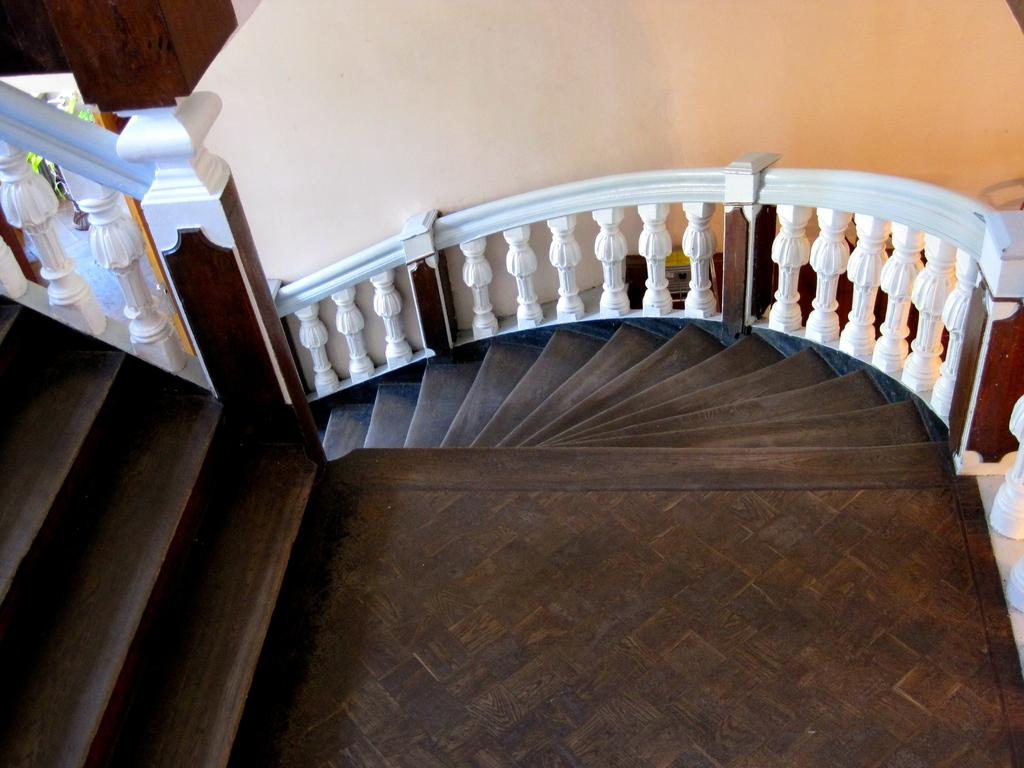What type of staircase is visible in the image? There is a wooden staircase in the image. What can be seen in the background of the image? There is a wall and a plant in the background of the image. What type of stitch is being used to repair the wooden staircase in the image? There is no indication in the image that the wooden staircase is being repaired, nor is there any mention of a stitch. 